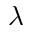Convert formula to latex. <formula><loc_0><loc_0><loc_500><loc_500>\lambda</formula> 